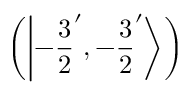<formula> <loc_0><loc_0><loc_500><loc_500>\left ( \left | - { \frac { 3 } { 2 } } ^ { \prime } , - { \frac { 3 } { 2 } } ^ { \prime } \right \rangle \right )</formula> 